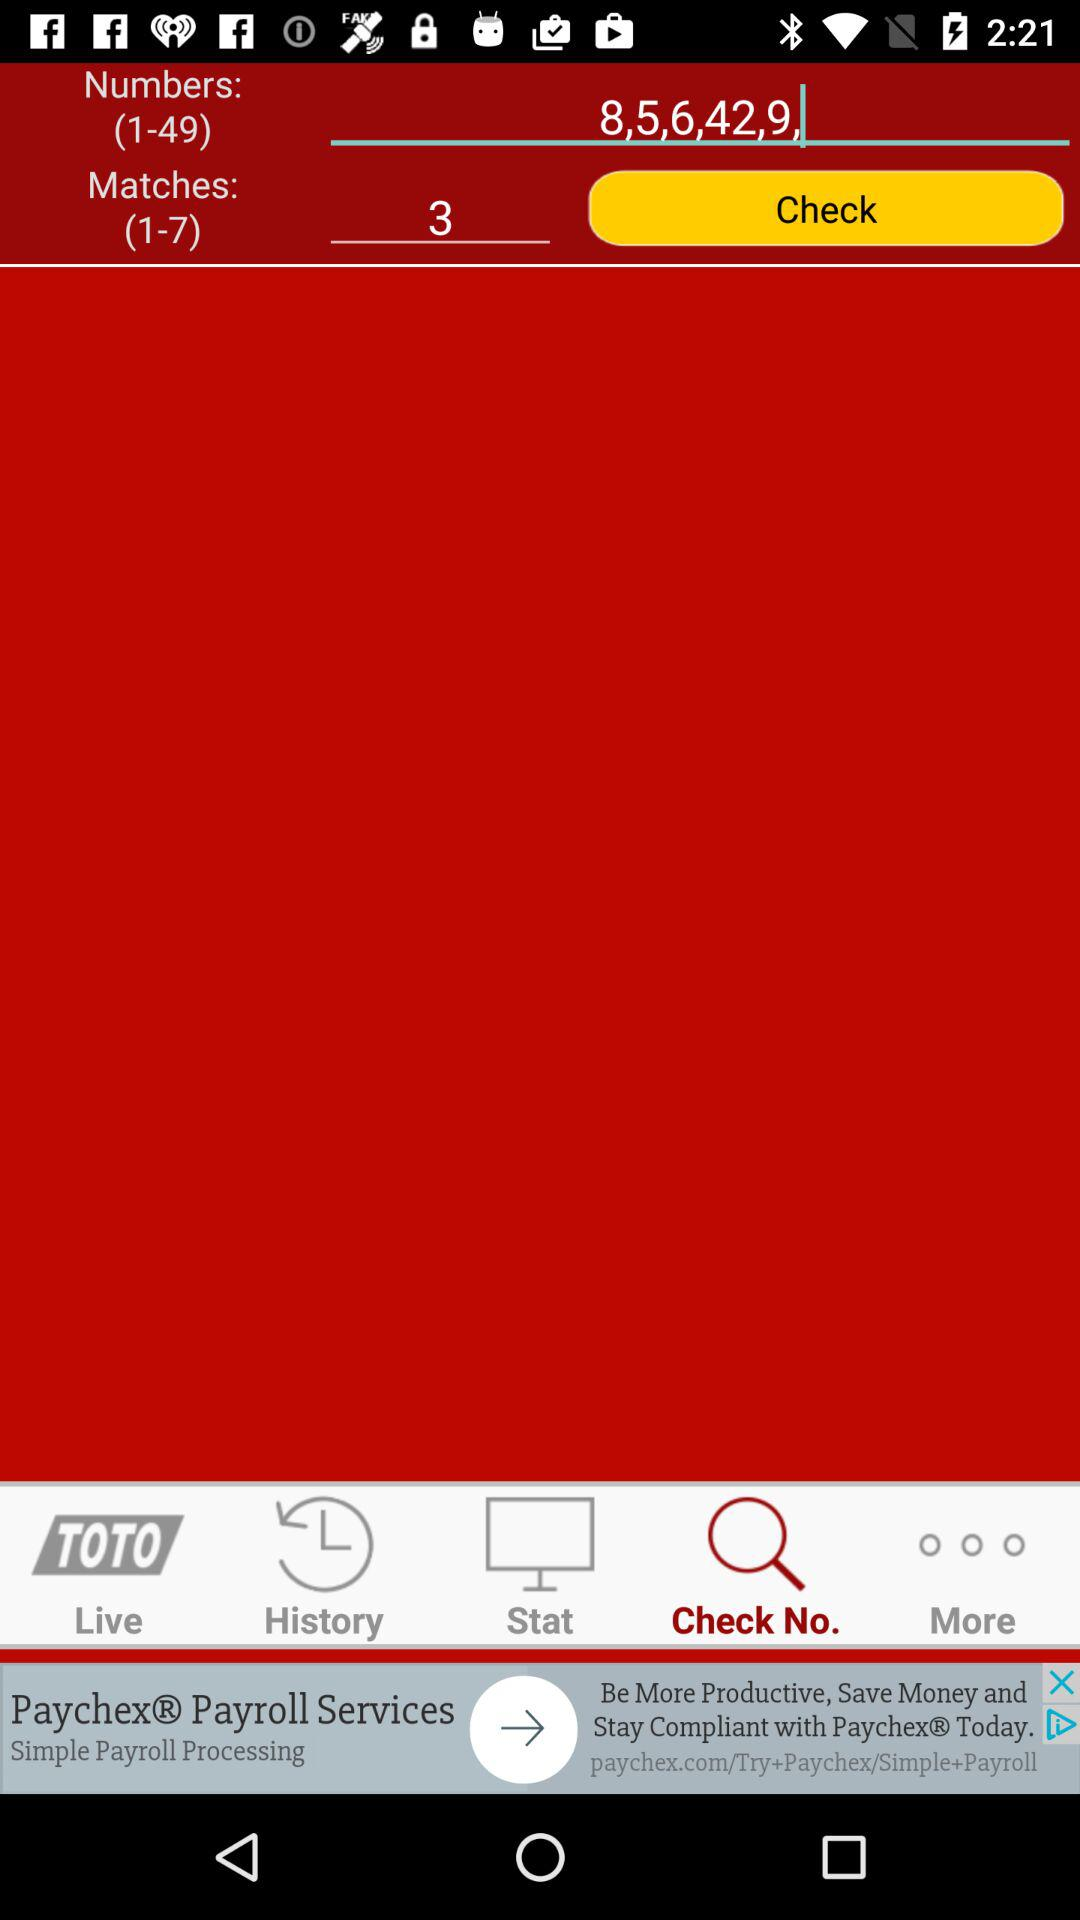Which tab am I on? You are on the "Check No." tab. 